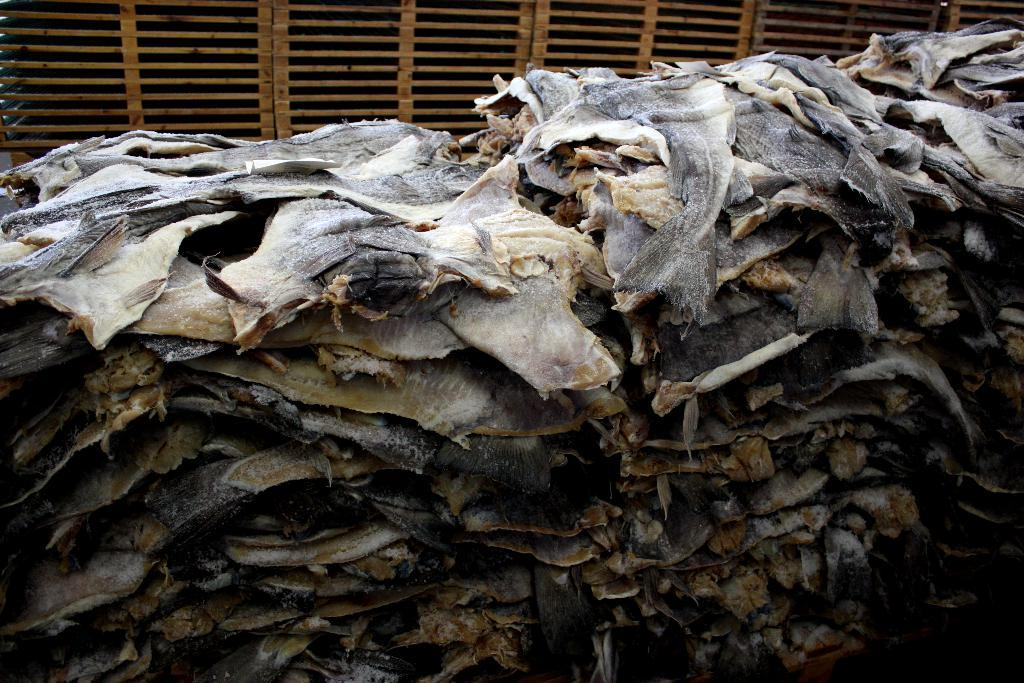What type of objects can be seen in the image? There are skins of fishes in the image. Are there any other objects present in the image besides the fish skins? Yes, there are other objects present in the image. How many bridges can be seen crossing the river in the image? There are no bridges visible in the image; it features fish skins and other unspecified objects. What type of bird is the turkey that can be seen in the image? There is no turkey present in the image. 